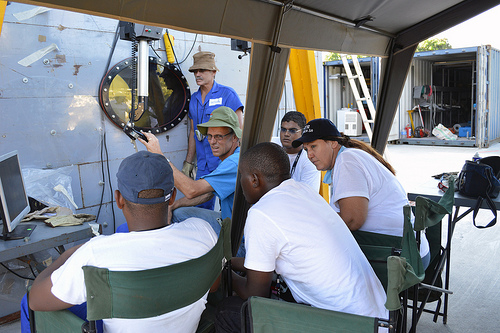<image>
Is the man on the chair? No. The man is not positioned on the chair. They may be near each other, but the man is not supported by or resting on top of the chair. 